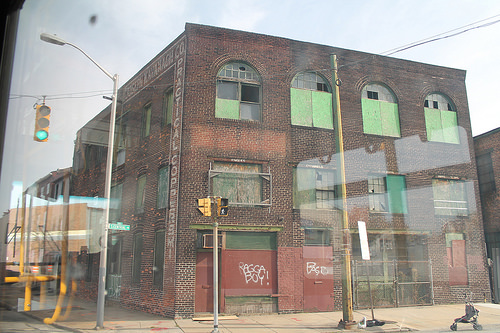<image>
Is there a building behind the pole? Yes. From this viewpoint, the building is positioned behind the pole, with the pole partially or fully occluding the building. 